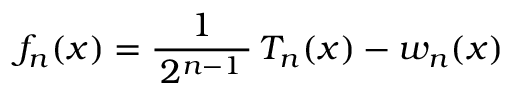<formula> <loc_0><loc_0><loc_500><loc_500>f _ { n } ( x ) = { \frac { 1 } { \, 2 ^ { n - 1 } \, } } \, T _ { n } ( x ) - w _ { n } ( x )</formula> 